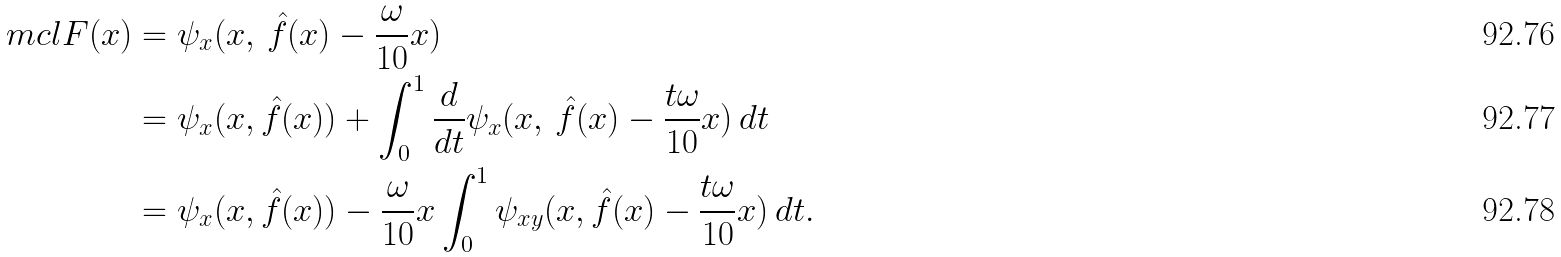<formula> <loc_0><loc_0><loc_500><loc_500>\ m c l { F } ( x ) & = \psi _ { x } ( x , \, \hat { f } ( x ) - \frac { \omega } { 1 0 } x ) \\ & = \psi _ { x } ( x , \hat { f } ( x ) ) + \int _ { 0 } ^ { 1 } \frac { d } { d t } \psi _ { x } ( x , \, \hat { f } ( x ) - \frac { t \omega } { 1 0 } x ) \, d t \\ & = \psi _ { x } ( x , \hat { f } ( x ) ) - \frac { \omega } { 1 0 } x \int _ { 0 } ^ { 1 } \psi _ { x y } ( x , \hat { f } ( x ) - \frac { t \omega } { 1 0 } x ) \, d t .</formula> 